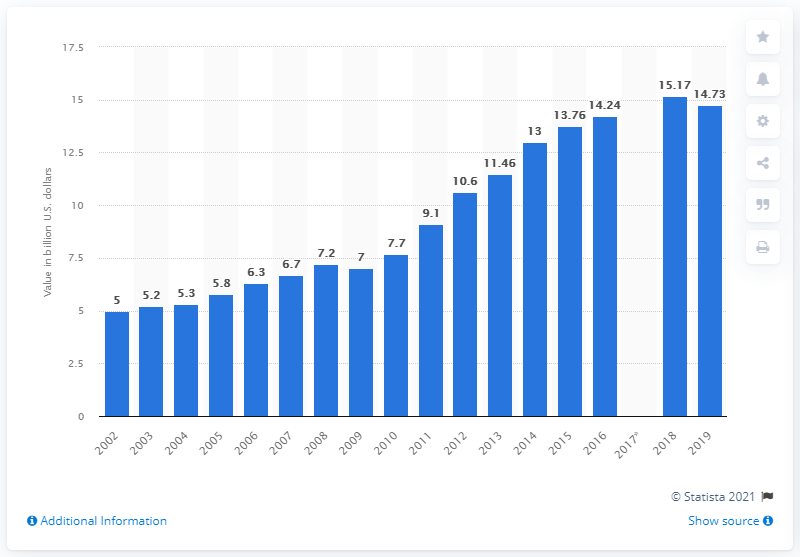Mention a couple of crucial points in this snapshot. In 2019, the value of roasted nuts and peanut butter in the United States was 14.73. 